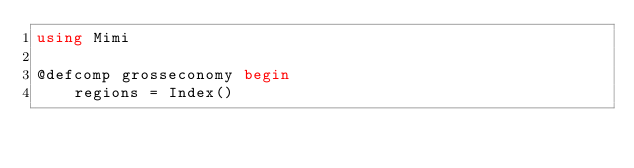Convert code to text. <code><loc_0><loc_0><loc_500><loc_500><_Julia_>using Mimi

@defcomp grosseconomy begin
    regions = Index()
</code> 